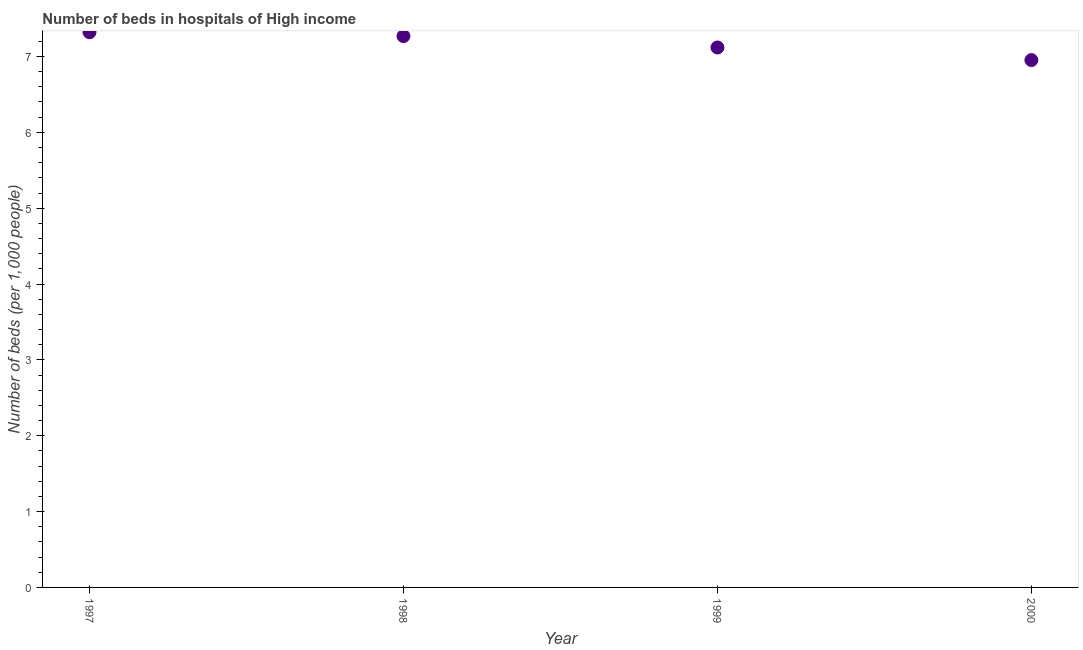What is the number of hospital beds in 1999?
Provide a succinct answer. 7.12. Across all years, what is the maximum number of hospital beds?
Your response must be concise. 7.32. Across all years, what is the minimum number of hospital beds?
Your answer should be compact. 6.95. What is the sum of the number of hospital beds?
Offer a terse response. 28.66. What is the difference between the number of hospital beds in 1997 and 2000?
Your answer should be compact. 0.37. What is the average number of hospital beds per year?
Make the answer very short. 7.16. What is the median number of hospital beds?
Your response must be concise. 7.19. Do a majority of the years between 1999 and 1998 (inclusive) have number of hospital beds greater than 5.2 %?
Offer a very short reply. No. What is the ratio of the number of hospital beds in 1999 to that in 2000?
Your response must be concise. 1.02. Is the difference between the number of hospital beds in 1997 and 1998 greater than the difference between any two years?
Your answer should be compact. No. What is the difference between the highest and the second highest number of hospital beds?
Provide a succinct answer. 0.05. What is the difference between the highest and the lowest number of hospital beds?
Your answer should be compact. 0.37. In how many years, is the number of hospital beds greater than the average number of hospital beds taken over all years?
Give a very brief answer. 2. How many dotlines are there?
Your response must be concise. 1. What is the difference between two consecutive major ticks on the Y-axis?
Ensure brevity in your answer.  1. Are the values on the major ticks of Y-axis written in scientific E-notation?
Your answer should be compact. No. Does the graph contain any zero values?
Provide a short and direct response. No. Does the graph contain grids?
Your answer should be compact. No. What is the title of the graph?
Your answer should be very brief. Number of beds in hospitals of High income. What is the label or title of the X-axis?
Give a very brief answer. Year. What is the label or title of the Y-axis?
Make the answer very short. Number of beds (per 1,0 people). What is the Number of beds (per 1,000 people) in 1997?
Your answer should be very brief. 7.32. What is the Number of beds (per 1,000 people) in 1998?
Your response must be concise. 7.27. What is the Number of beds (per 1,000 people) in 1999?
Your answer should be very brief. 7.12. What is the Number of beds (per 1,000 people) in 2000?
Your answer should be very brief. 6.95. What is the difference between the Number of beds (per 1,000 people) in 1997 and 1998?
Offer a terse response. 0.05. What is the difference between the Number of beds (per 1,000 people) in 1997 and 1999?
Give a very brief answer. 0.2. What is the difference between the Number of beds (per 1,000 people) in 1997 and 2000?
Your answer should be very brief. 0.37. What is the difference between the Number of beds (per 1,000 people) in 1998 and 1999?
Provide a succinct answer. 0.15. What is the difference between the Number of beds (per 1,000 people) in 1998 and 2000?
Provide a short and direct response. 0.32. What is the difference between the Number of beds (per 1,000 people) in 1999 and 2000?
Keep it short and to the point. 0.17. What is the ratio of the Number of beds (per 1,000 people) in 1997 to that in 1999?
Offer a very short reply. 1.03. What is the ratio of the Number of beds (per 1,000 people) in 1997 to that in 2000?
Offer a very short reply. 1.05. What is the ratio of the Number of beds (per 1,000 people) in 1998 to that in 2000?
Provide a short and direct response. 1.05. 